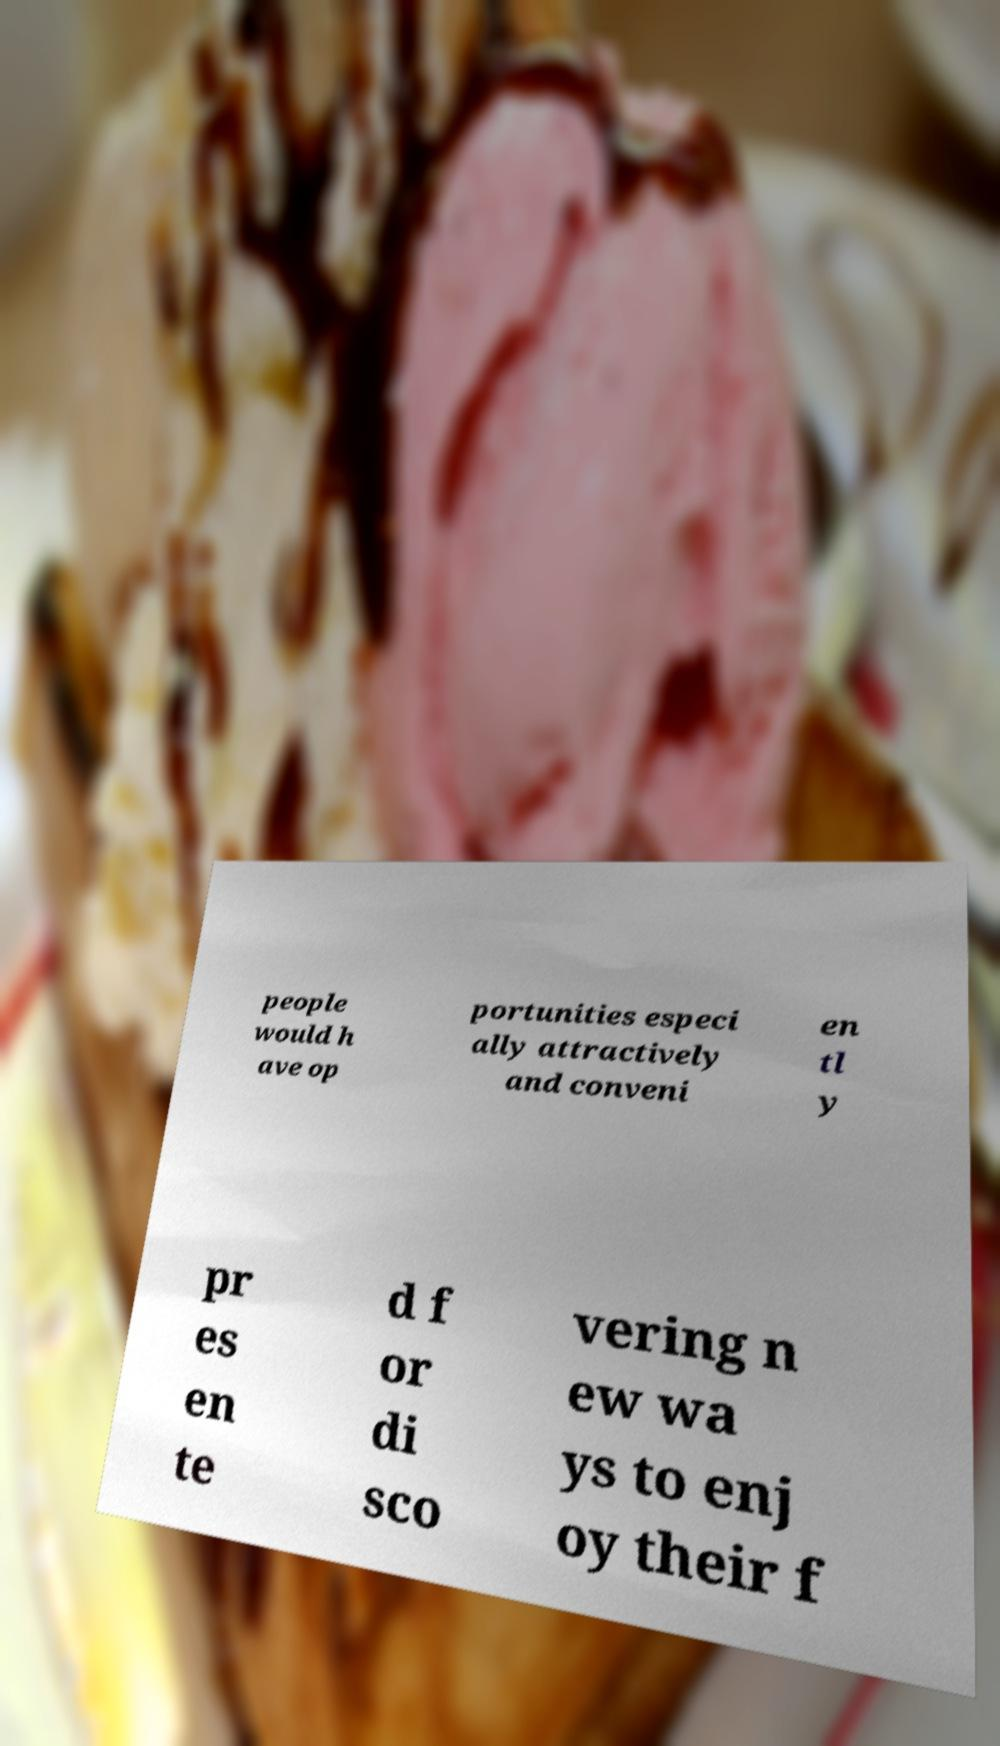Please read and relay the text visible in this image. What does it say? people would h ave op portunities especi ally attractively and conveni en tl y pr es en te d f or di sco vering n ew wa ys to enj oy their f 